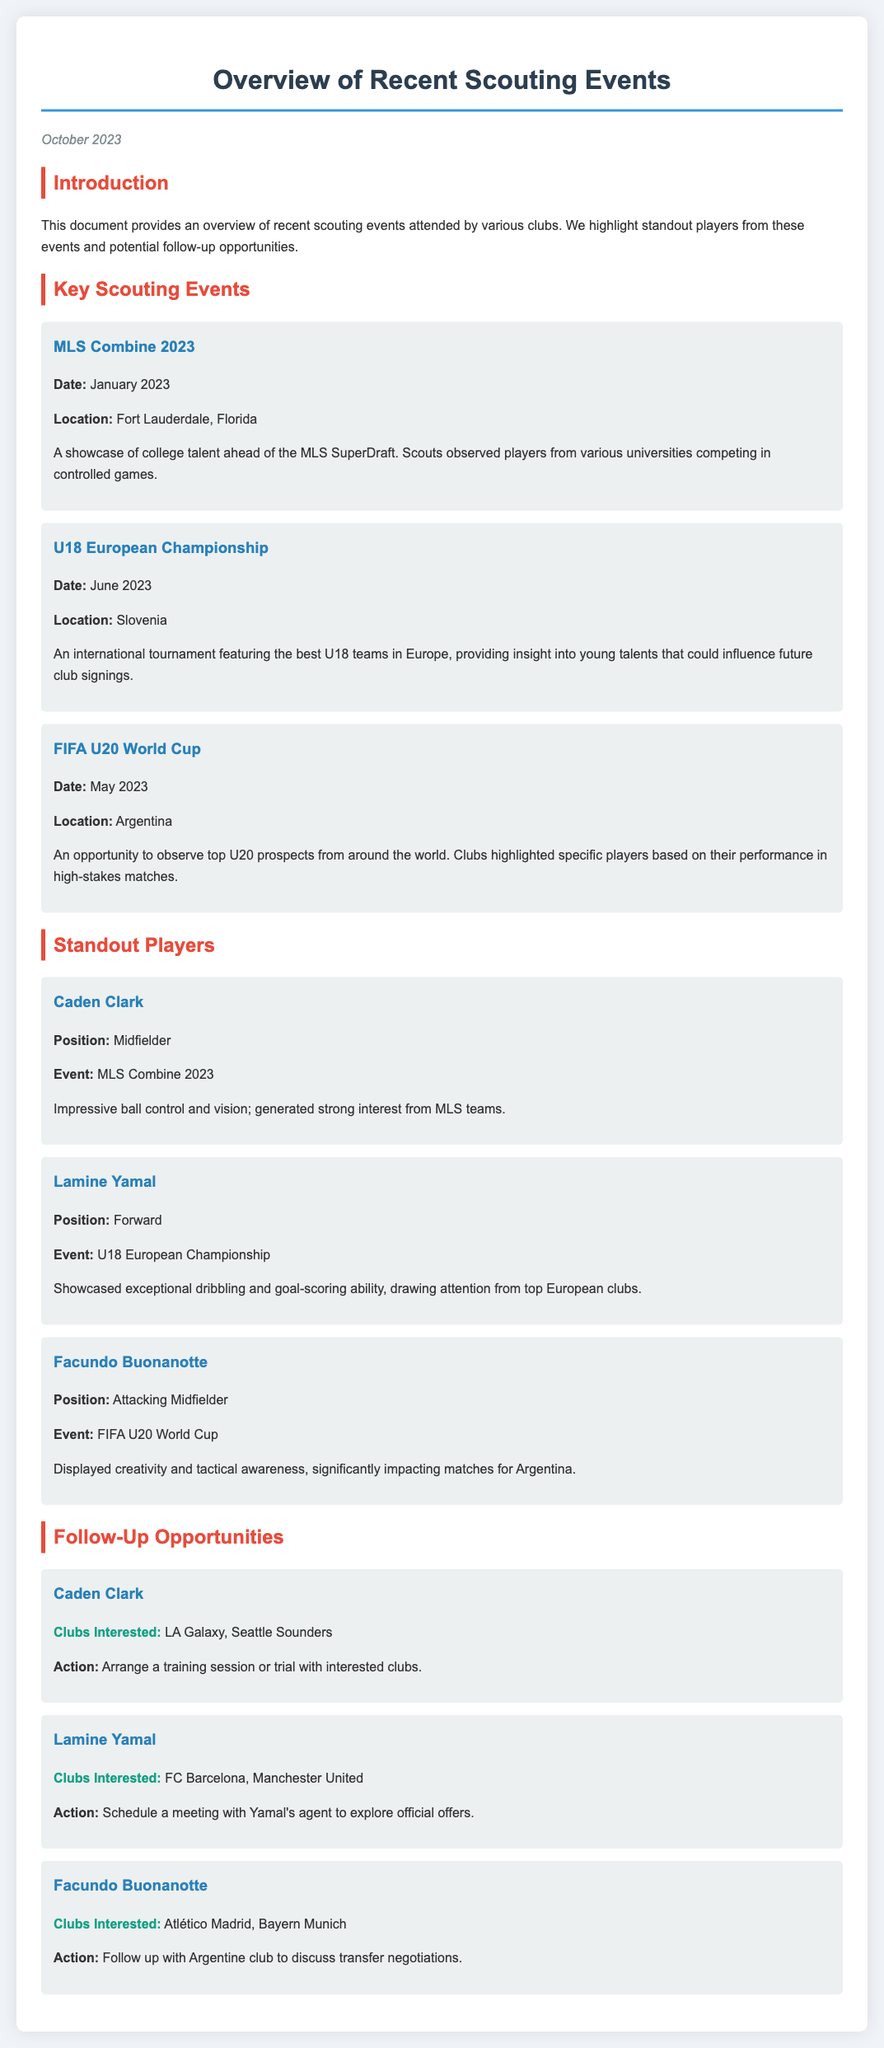What was the date of the MLS Combine? The document specifies that the MLS Combine took place in January 2023.
Answer: January 2023 Where was the U18 European Championship held? The location is mentioned in the document as Slovenia.
Answer: Slovenia Who is the standout player from the FIFA U20 World Cup? The document lists Facundo Buonanotte as a standout player from this event.
Answer: Facundo Buonanotte Which club is interested in Caden Clark? The document indicates that LA Galaxy is one of the clubs interested in him.
Answer: LA Galaxy What position does Lamine Yamal play? The document specifies that he plays as a forward.
Answer: Forward What action is proposed for Lamine Yamal? The document suggests scheduling a meeting with Yamal's agent to explore official offers.
Answer: Schedule a meeting with Yamal's agent Which player showcased creativity and tactical awareness? The document highlights that Facundo Buonanotte displayed these skills.
Answer: Facundo Buonanotte How many clubs are interested in Facundo Buonanotte? The document mentions two clubs interested in him: Atlético Madrid and Bayern Munich.
Answer: Two clubs What is the location of the FIFA U20 World Cup? The document states that it was held in Argentina.
Answer: Argentina 